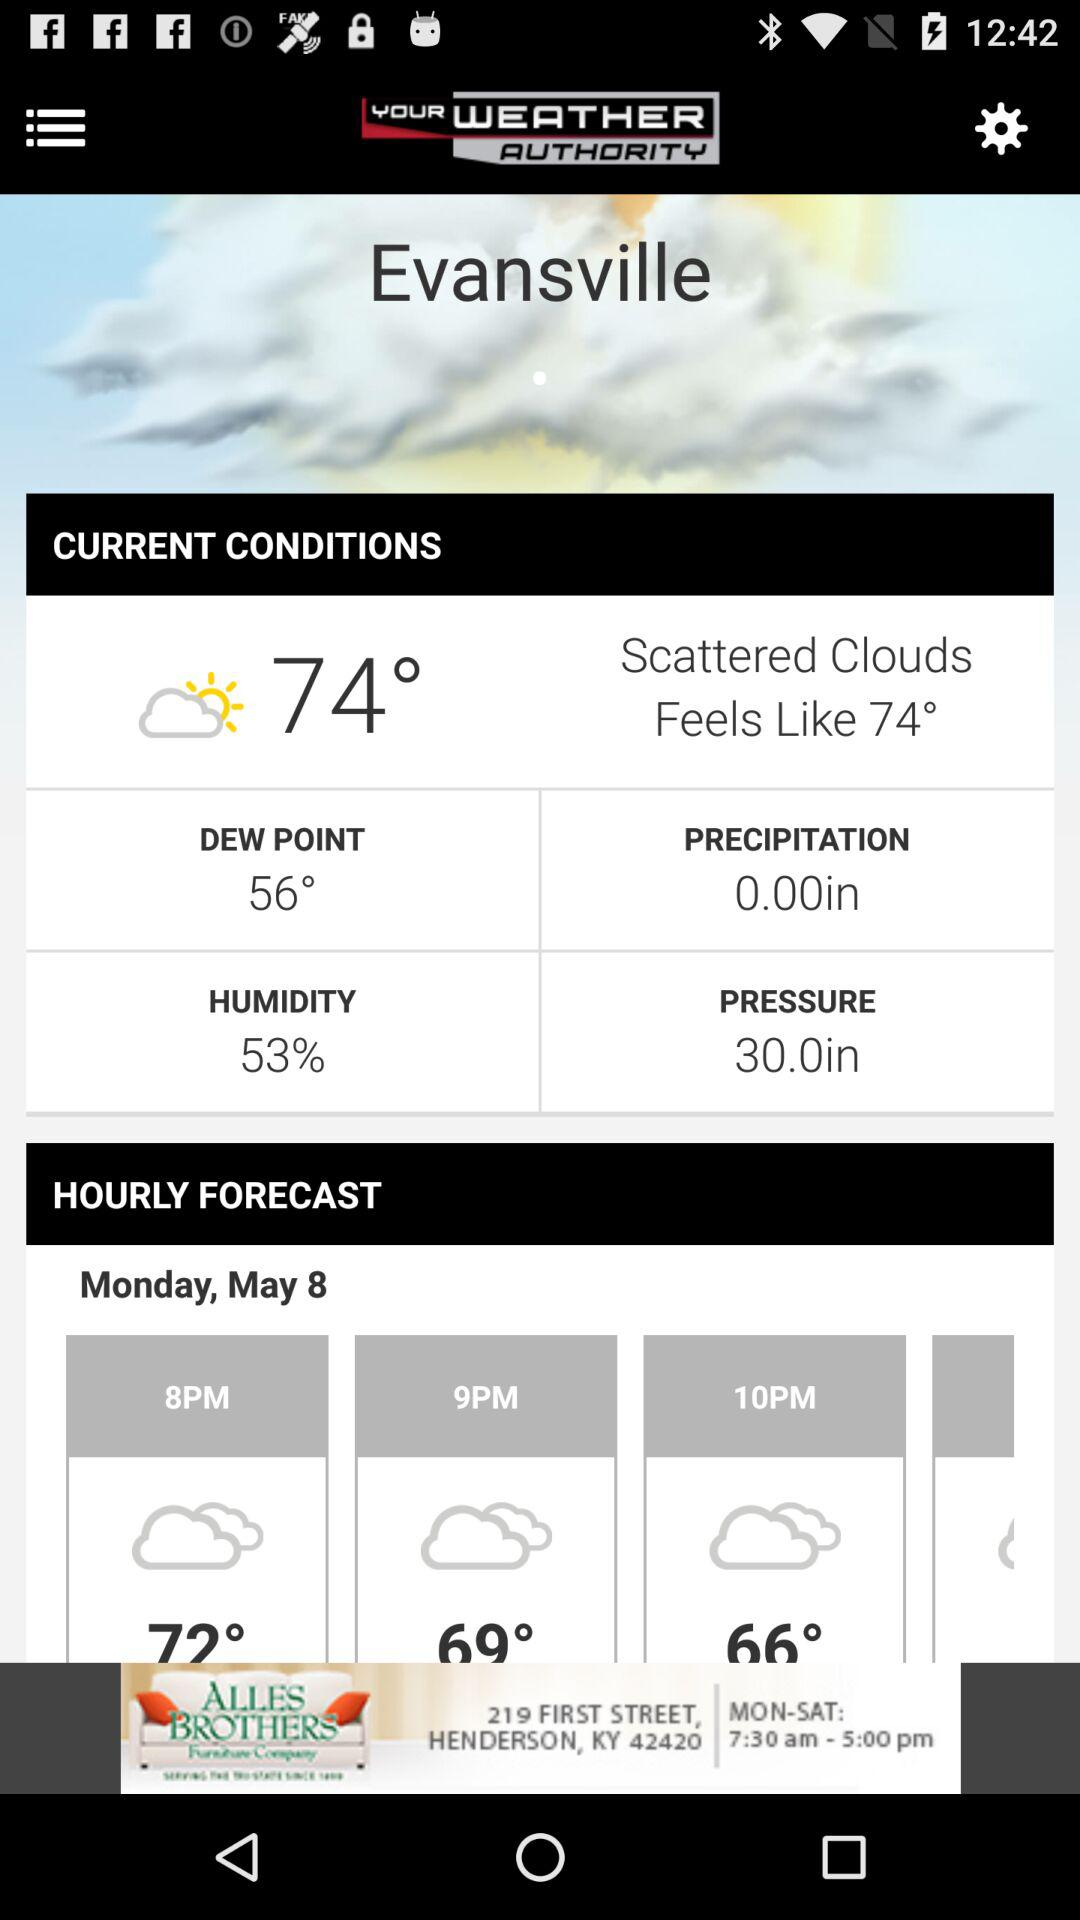What is the current temperature? The current temperature is 74 degrees. 